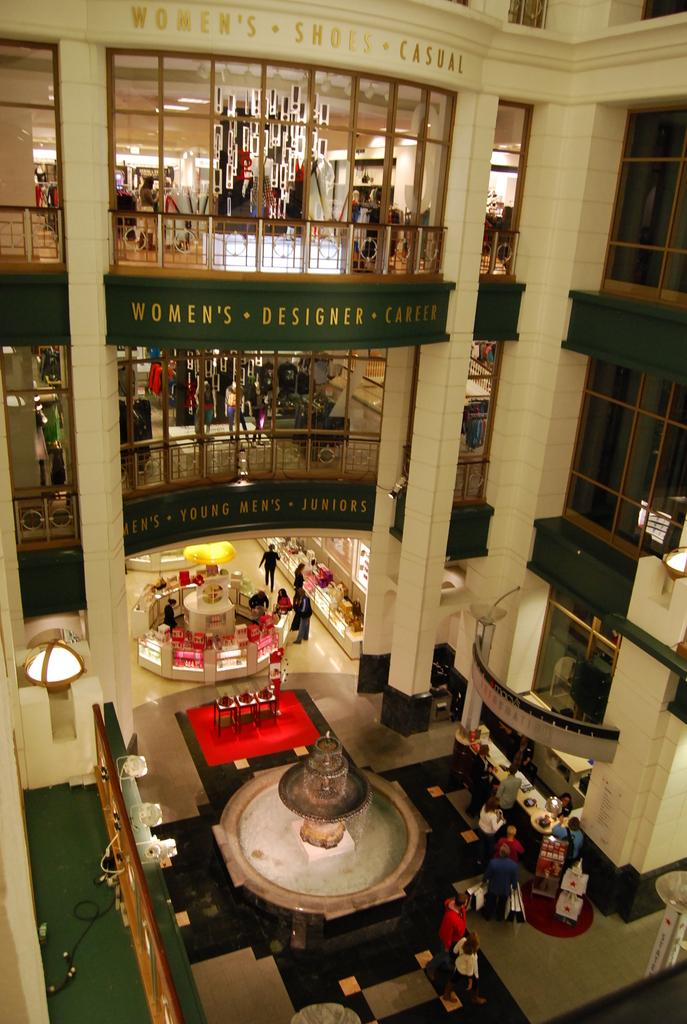What type of building is shown in the image? The image depicts a mall. How many floors of stores are visible in the image? There are stores in two floors of the mall. What can be found in the middle of the bottom floor? There is a fountain in the middle of the bottom floor. Are there any people near the fountain? Yes, there are people around the fountain. Can you tell me how many times the people around the fountain are shaking hands in the image? There is no information about people shaking hands in the image; it only shows people around the fountain. Is there any smoke visible in the image? No, there is no smoke present in the image. 